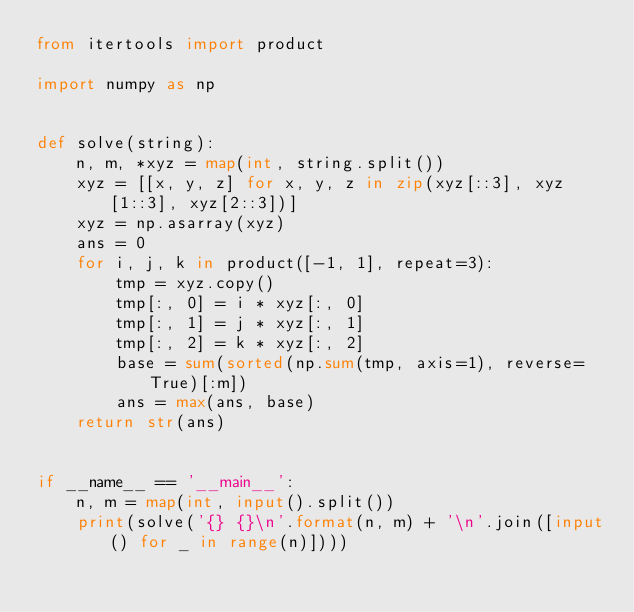Convert code to text. <code><loc_0><loc_0><loc_500><loc_500><_Python_>from itertools import product

import numpy as np


def solve(string):
    n, m, *xyz = map(int, string.split())
    xyz = [[x, y, z] for x, y, z in zip(xyz[::3], xyz[1::3], xyz[2::3])]
    xyz = np.asarray(xyz)
    ans = 0
    for i, j, k in product([-1, 1], repeat=3):
        tmp = xyz.copy()
        tmp[:, 0] = i * xyz[:, 0]
        tmp[:, 1] = j * xyz[:, 1]
        tmp[:, 2] = k * xyz[:, 2]
        base = sum(sorted(np.sum(tmp, axis=1), reverse=True)[:m])
        ans = max(ans, base)
    return str(ans)


if __name__ == '__main__':
    n, m = map(int, input().split())
    print(solve('{} {}\n'.format(n, m) + '\n'.join([input() for _ in range(n)])))
</code> 